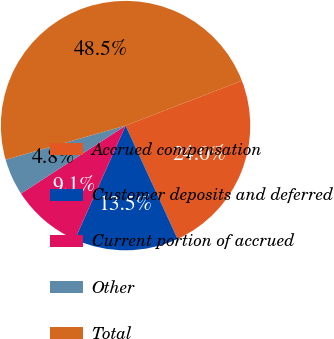<chart> <loc_0><loc_0><loc_500><loc_500><pie_chart><fcel>Accrued compensation<fcel>Customer deposits and deferred<fcel>Current portion of accrued<fcel>Other<fcel>Total<nl><fcel>24.01%<fcel>13.52%<fcel>9.15%<fcel>4.77%<fcel>48.55%<nl></chart> 